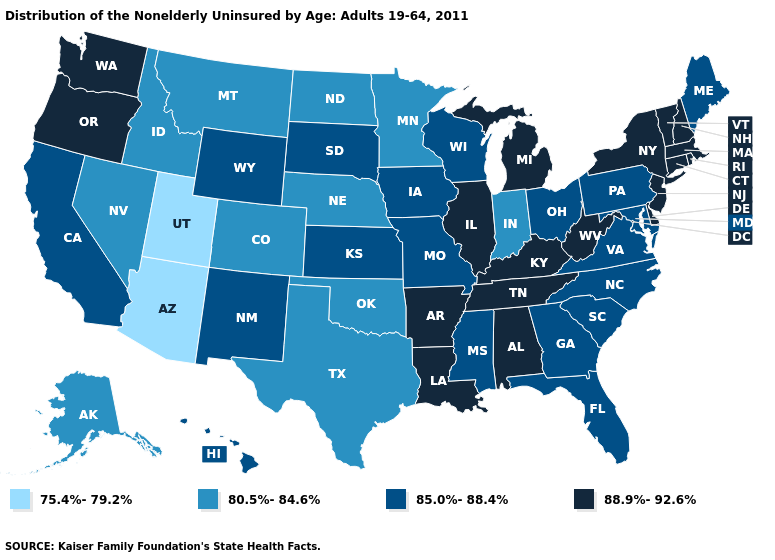Name the states that have a value in the range 88.9%-92.6%?
Be succinct. Alabama, Arkansas, Connecticut, Delaware, Illinois, Kentucky, Louisiana, Massachusetts, Michigan, New Hampshire, New Jersey, New York, Oregon, Rhode Island, Tennessee, Vermont, Washington, West Virginia. Which states hav the highest value in the MidWest?
Give a very brief answer. Illinois, Michigan. Which states have the highest value in the USA?
Be succinct. Alabama, Arkansas, Connecticut, Delaware, Illinois, Kentucky, Louisiana, Massachusetts, Michigan, New Hampshire, New Jersey, New York, Oregon, Rhode Island, Tennessee, Vermont, Washington, West Virginia. What is the value of Alaska?
Keep it brief. 80.5%-84.6%. Does Arizona have the lowest value in the USA?
Give a very brief answer. Yes. What is the value of Alaska?
Keep it brief. 80.5%-84.6%. Which states have the highest value in the USA?
Concise answer only. Alabama, Arkansas, Connecticut, Delaware, Illinois, Kentucky, Louisiana, Massachusetts, Michigan, New Hampshire, New Jersey, New York, Oregon, Rhode Island, Tennessee, Vermont, Washington, West Virginia. Among the states that border Ohio , does Indiana have the lowest value?
Answer briefly. Yes. Name the states that have a value in the range 85.0%-88.4%?
Quick response, please. California, Florida, Georgia, Hawaii, Iowa, Kansas, Maine, Maryland, Mississippi, Missouri, New Mexico, North Carolina, Ohio, Pennsylvania, South Carolina, South Dakota, Virginia, Wisconsin, Wyoming. What is the value of Nevada?
Quick response, please. 80.5%-84.6%. Does Illinois have the lowest value in the MidWest?
Concise answer only. No. Name the states that have a value in the range 85.0%-88.4%?
Keep it brief. California, Florida, Georgia, Hawaii, Iowa, Kansas, Maine, Maryland, Mississippi, Missouri, New Mexico, North Carolina, Ohio, Pennsylvania, South Carolina, South Dakota, Virginia, Wisconsin, Wyoming. Is the legend a continuous bar?
Concise answer only. No. What is the highest value in the USA?
Give a very brief answer. 88.9%-92.6%. Does Oklahoma have the lowest value in the South?
Write a very short answer. Yes. 